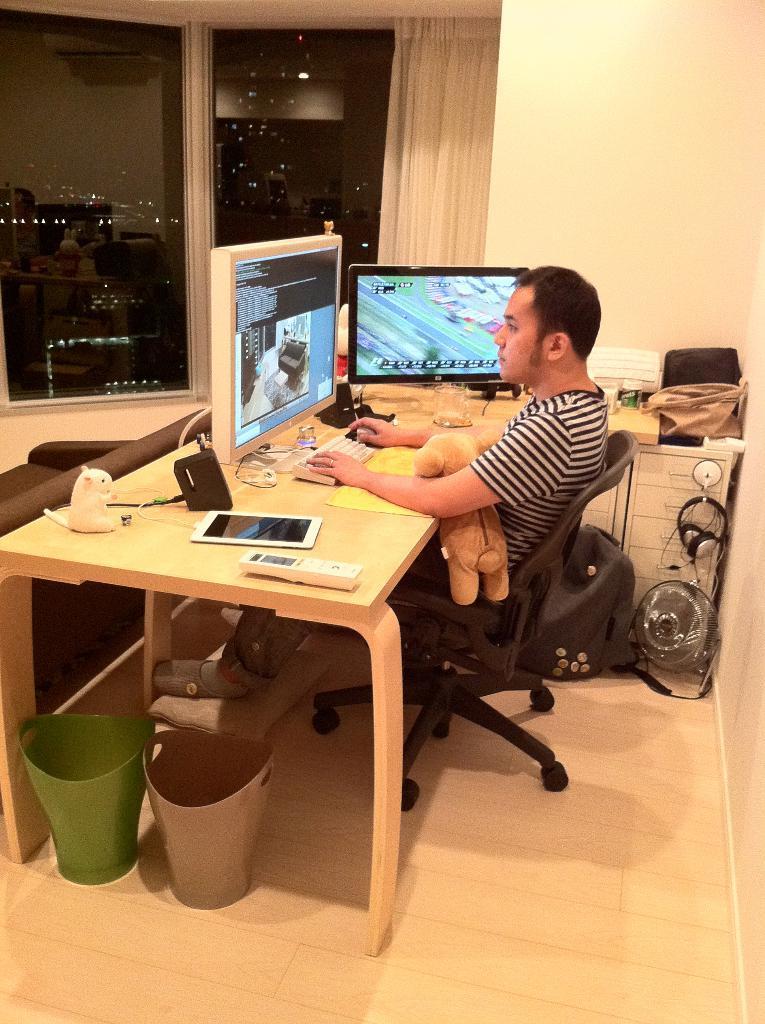Please provide a concise description of this image. In the center of the image we can see one person sitting on the chair and he is holding a toy. In front of him, there is a table. On the table, we can see the monitors, tab, remote, toy, keyboard, bag, machine and a few other objects. In the background there is a wall, window, curtain, fan, bag, sofa, dust bins, drawers etc. 